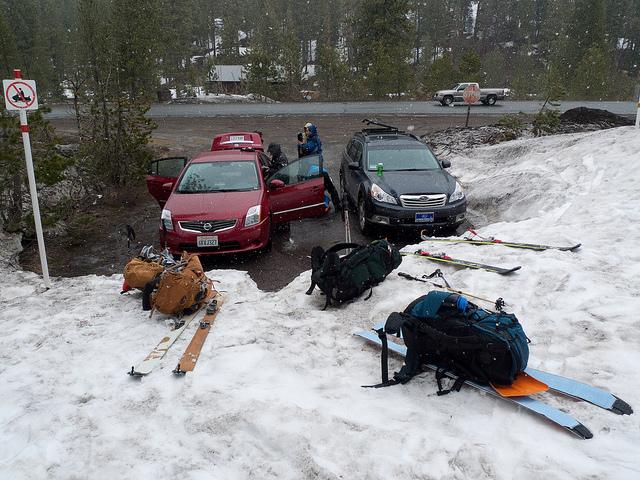What sort of outing are they embarking on? Please explain your reasoning. skiing. The outing is skiing. 